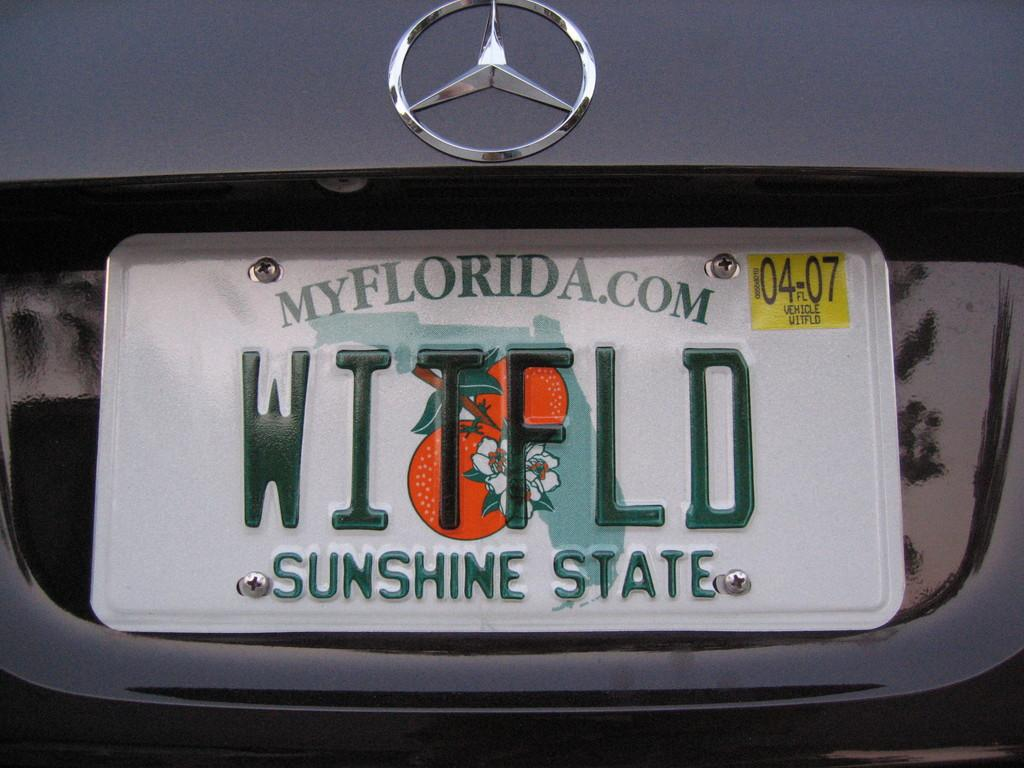<image>
Create a compact narrative representing the image presented. A Mercedes has a Florida license plate that says "sunshine state" at the bottom. 